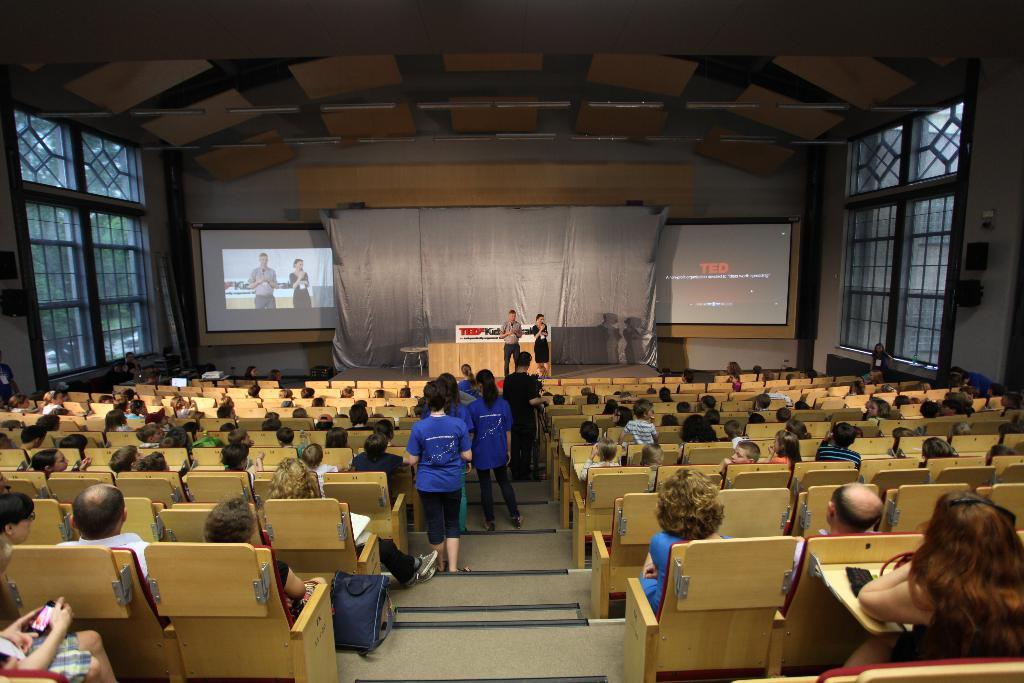What are the people in the image doing? There is a group of people sitting on chairs and a group of people standing in the image. What can be seen on the stage in the image? The presence of a stage suggests that there might be a performance or presentation taking place. What is on the table in the image? There is a table in the image, but the facts do not specify what is on it. How many chairs are visible in the image? There are chairs in the image, but the facts do not specify the exact number. What type of screens are present in the image? The screens in the image could be used for displaying information or visuals related to the event or performance. What can be seen through the windows in the image? The windows in the image provide a view of the surroundings, but the facts do not specify what can be seen through them. What are the speakers used for in the image? The speakers in the image are likely used for amplifying sound, such as music or speeches, during the event or performance. What thought is shared among the people in the image? The image does not depict any thoughts or emotions of the people; it only shows their physical positions and the presence of various objects. How do the people in the image say good-bye to each other? The image does not show any interactions between the people, such as saying good-bye, so it cannot be determined from the image. 